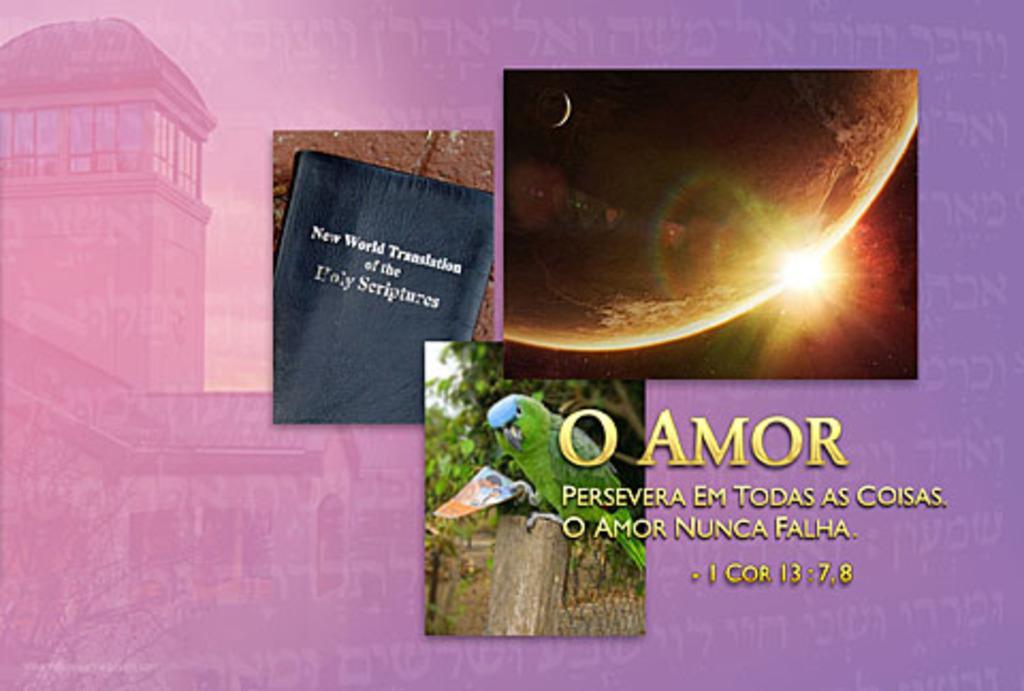Could you give a brief overview of what you see in this image? This image edited and made as a collage image. Here I can see three pictures. In the left side picture there is a book on which I can see some text. In the right side picture there is a planet. In the bottom image there is a parrot on a wooden plank and it is holding a photo. In the background there are few trees. On this image I can see some edited text. In the background there is a building. 